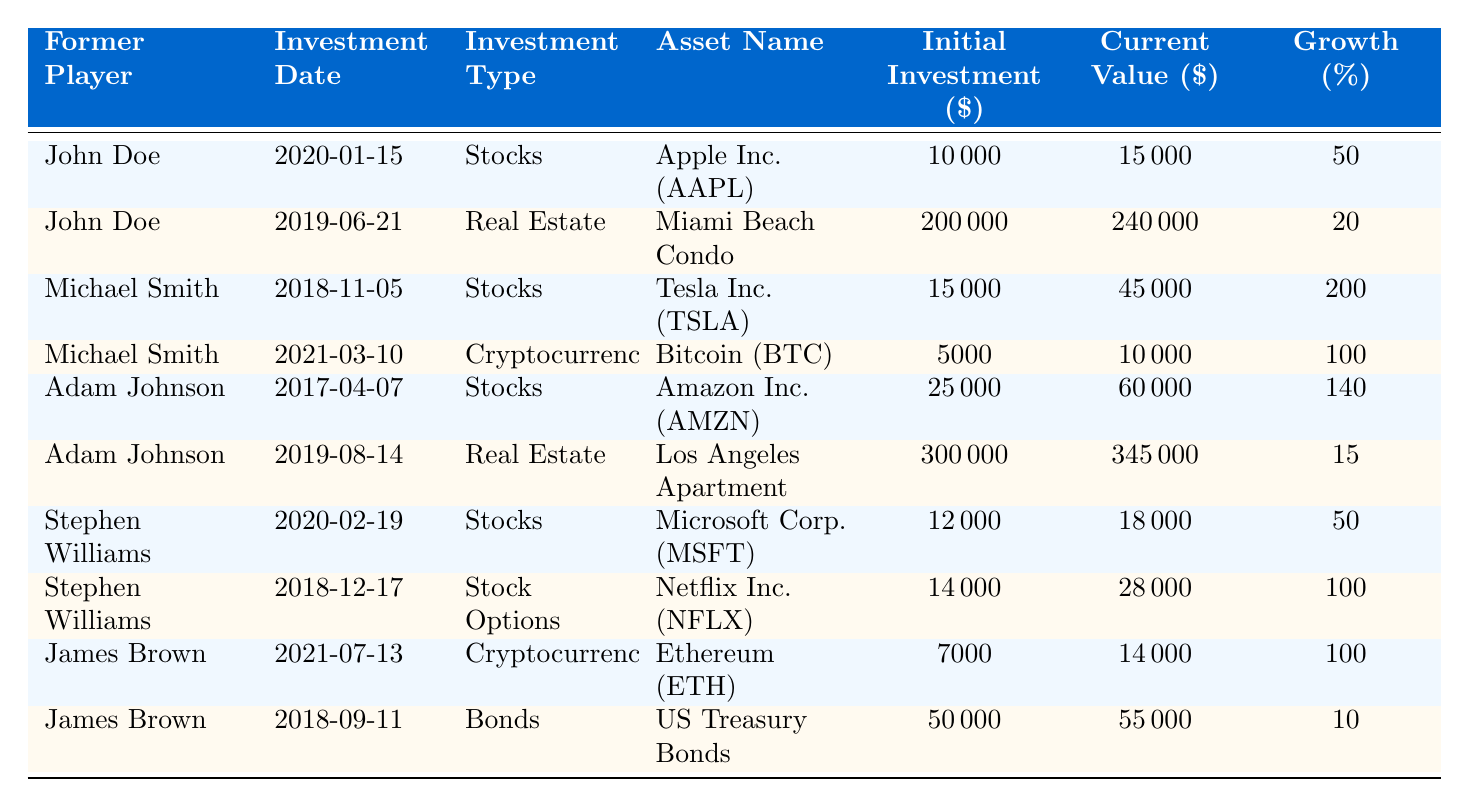What is the current value of John Doe's investment in Apple Inc.? According to the table, John Doe's current value for the investment in Apple Inc. is listed under the "Current Value ($)" column for the row corresponding to his investment on "2020-01-15." This value is $15,000.
Answer: 15000 What is the percentage growth of Adam Johnson's investment in Amazon Inc.? For Adam Johnson's investment in Amazon Inc., the percentage growth is indicated in the "Growth (%)" column. The value for this investment is 140%.
Answer: 140 Which former player made the highest percentage growth on their investments? Looking through the table, Michael Smith has the highest percentage growth listed for Tesla Inc. at 200%. This percentage is found in the column for percentage growth for the relevant investment.
Answer: Michael Smith What is the total initial investment amount for all of James Brown's investments? James Brown has made two investments. The initial amounts are $7,000 for Ethereum and $50,000 for US Treasury Bonds. Adding these together results in a total of $7,000 + $50,000 = $57,000.
Answer: 57000 Did Stephen Williams invest in Real Estate? By examining the table, we find that Stephen Williams has only investments in Stocks and Stock Options, with no investments listed under Real Estate in the relevant column. This results in a "no" answer.
Answer: No What is the average current value of John Doe's investments? John Doe has two investments: one in Apple Inc. ($15,000) and one in Miami Beach Condo ($240,000). The total current value is $15,000 + $240,000 = $255,000. To find the average, we divide by the number of investments: $255,000 / 2 = $127,500.
Answer: 127500 How many former players have invested in Cryptocurrency? The table shows that both Michael Smith (Bitcoin) and James Brown (Ethereum) have made investments in Cryptocurrency, which totals to two players. Counting the rows where "Investment Type" is Cryptocurrency confirms this.
Answer: 2 Which investment type has the highest current value of assets? By reviewing the table, the highest current value listed is for Adam Johnson's investment in Real Estate, with a value of $345,000. Since "Real Estate" corresponds to the highest figure in the "Current Value ($)" column, this is the answer.
Answer: Real Estate 